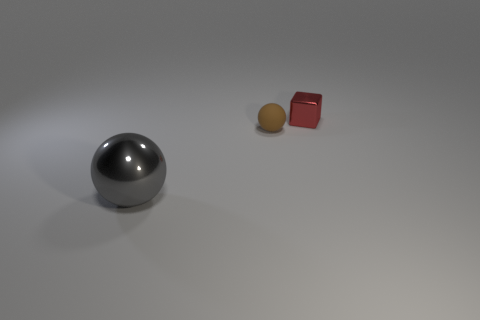How many other things are there of the same size as the red object?
Offer a terse response. 1. There is a matte thing; how many large gray shiny balls are behind it?
Make the answer very short. 0. The gray shiny sphere is what size?
Give a very brief answer. Large. Does the object on the right side of the brown matte object have the same material as the small object in front of the red metallic cube?
Offer a very short reply. No. Is there another rubber ball that has the same color as the tiny matte sphere?
Give a very brief answer. No. The other metallic object that is the same size as the brown thing is what color?
Offer a terse response. Red. Do the tiny object in front of the small red block and the large metallic thing have the same color?
Provide a short and direct response. No. Are there any green things made of the same material as the brown sphere?
Give a very brief answer. No. Are there fewer red blocks behind the red cube than cyan rubber blocks?
Keep it short and to the point. No. There is a red object right of the brown ball; is its size the same as the brown rubber ball?
Your answer should be compact. Yes. 